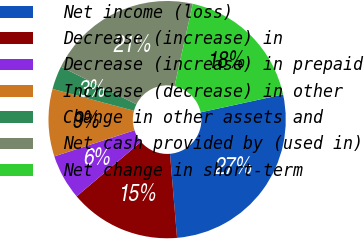Convert chart. <chart><loc_0><loc_0><loc_500><loc_500><pie_chart><fcel>Net income (loss)<fcel>Decrease (increase) in<fcel>Decrease (increase) in prepaid<fcel>Increase (decrease) in other<fcel>Change in other assets and<fcel>Net cash provided by (used in)<fcel>Net change in short-term<nl><fcel>27.08%<fcel>15.14%<fcel>6.18%<fcel>9.17%<fcel>3.2%<fcel>21.11%<fcel>18.12%<nl></chart> 